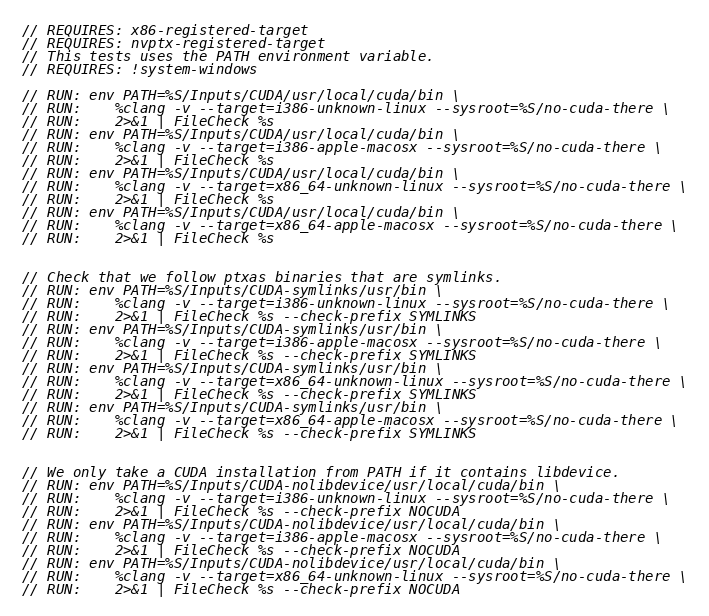Convert code to text. <code><loc_0><loc_0><loc_500><loc_500><_Cuda_>// REQUIRES: x86-registered-target
// REQUIRES: nvptx-registered-target
// This tests uses the PATH environment variable.
// REQUIRES: !system-windows

// RUN: env PATH=%S/Inputs/CUDA/usr/local/cuda/bin \
// RUN:    %clang -v --target=i386-unknown-linux --sysroot=%S/no-cuda-there \
// RUN:    2>&1 | FileCheck %s
// RUN: env PATH=%S/Inputs/CUDA/usr/local/cuda/bin \
// RUN:    %clang -v --target=i386-apple-macosx --sysroot=%S/no-cuda-there \
// RUN:    2>&1 | FileCheck %s
// RUN: env PATH=%S/Inputs/CUDA/usr/local/cuda/bin \
// RUN:    %clang -v --target=x86_64-unknown-linux --sysroot=%S/no-cuda-there \
// RUN:    2>&1 | FileCheck %s
// RUN: env PATH=%S/Inputs/CUDA/usr/local/cuda/bin \
// RUN:    %clang -v --target=x86_64-apple-macosx --sysroot=%S/no-cuda-there \
// RUN:    2>&1 | FileCheck %s


// Check that we follow ptxas binaries that are symlinks.
// RUN: env PATH=%S/Inputs/CUDA-symlinks/usr/bin \
// RUN:    %clang -v --target=i386-unknown-linux --sysroot=%S/no-cuda-there \
// RUN:    2>&1 | FileCheck %s --check-prefix SYMLINKS
// RUN: env PATH=%S/Inputs/CUDA-symlinks/usr/bin \
// RUN:    %clang -v --target=i386-apple-macosx --sysroot=%S/no-cuda-there \
// RUN:    2>&1 | FileCheck %s --check-prefix SYMLINKS
// RUN: env PATH=%S/Inputs/CUDA-symlinks/usr/bin \
// RUN:    %clang -v --target=x86_64-unknown-linux --sysroot=%S/no-cuda-there \
// RUN:    2>&1 | FileCheck %s --check-prefix SYMLINKS
// RUN: env PATH=%S/Inputs/CUDA-symlinks/usr/bin \
// RUN:    %clang -v --target=x86_64-apple-macosx --sysroot=%S/no-cuda-there \
// RUN:    2>&1 | FileCheck %s --check-prefix SYMLINKS


// We only take a CUDA installation from PATH if it contains libdevice.
// RUN: env PATH=%S/Inputs/CUDA-nolibdevice/usr/local/cuda/bin \
// RUN:    %clang -v --target=i386-unknown-linux --sysroot=%S/no-cuda-there \
// RUN:    2>&1 | FileCheck %s --check-prefix NOCUDA
// RUN: env PATH=%S/Inputs/CUDA-nolibdevice/usr/local/cuda/bin \
// RUN:    %clang -v --target=i386-apple-macosx --sysroot=%S/no-cuda-there \
// RUN:    2>&1 | FileCheck %s --check-prefix NOCUDA
// RUN: env PATH=%S/Inputs/CUDA-nolibdevice/usr/local/cuda/bin \
// RUN:    %clang -v --target=x86_64-unknown-linux --sysroot=%S/no-cuda-there \
// RUN:    2>&1 | FileCheck %s --check-prefix NOCUDA</code> 